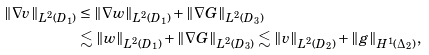Convert formula to latex. <formula><loc_0><loc_0><loc_500><loc_500>\| \nabla v \| _ { L ^ { 2 } ( D _ { 1 } ) } & \leq \| \nabla w \| _ { L ^ { 2 } ( D _ { 1 } ) } + \| \nabla G \| _ { L ^ { 2 } ( D _ { 3 } ) } \\ & \lesssim \| w \| _ { L ^ { 2 } ( D _ { 1 } ) } + \| \nabla G \| _ { L ^ { 2 } ( D _ { 3 } ) } \lesssim \| v \| _ { L ^ { 2 } ( D _ { 2 } ) } + \| g \| _ { H ^ { 1 } ( \Delta _ { 2 } ) } ,</formula> 